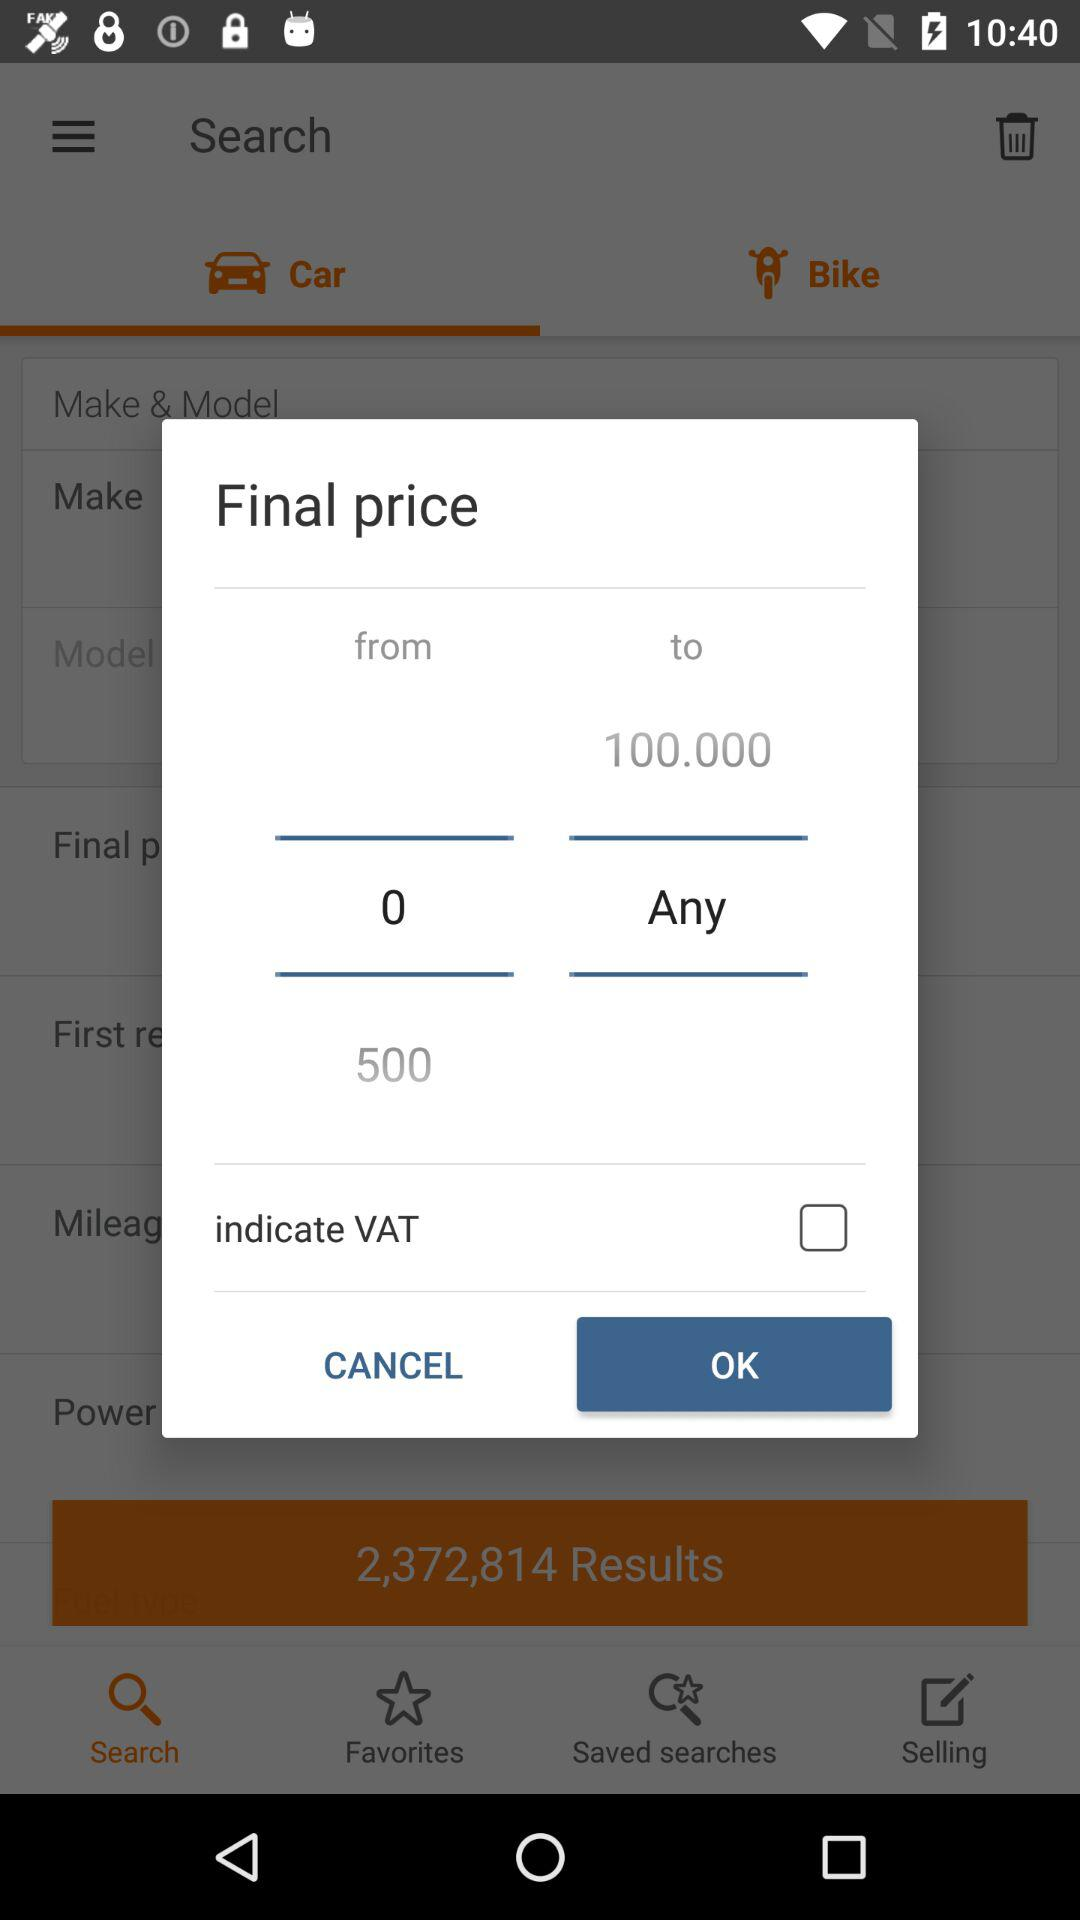What is the status of the "indicate VAT"? The status is "off". 